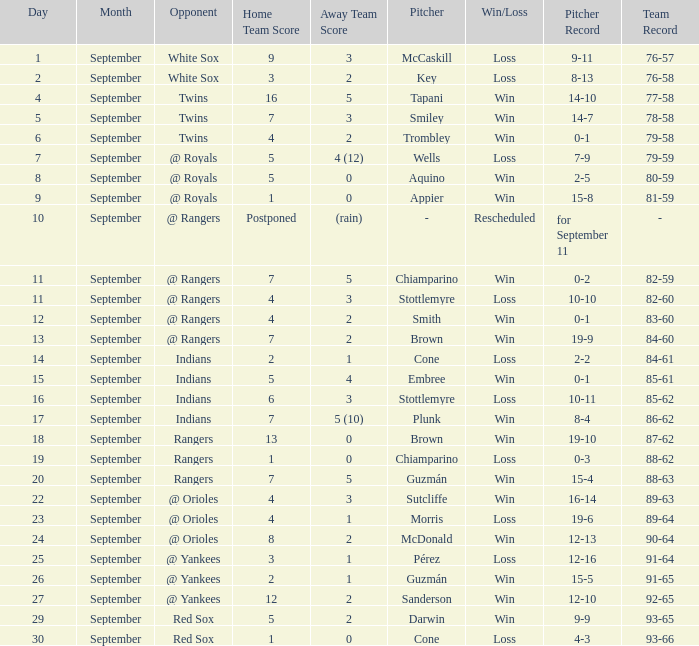Write the full table. {'header': ['Day', 'Month', 'Opponent', 'Home Team Score', 'Away Team Score', 'Pitcher', 'Win/Loss', 'Pitcher Record', 'Team Record'], 'rows': [['1', 'September', 'White Sox', '9', '3', 'McCaskill', 'Loss', '9-11', '76-57'], ['2', 'September', 'White Sox', '3', '2', 'Key', 'Loss', '8-13', '76-58'], ['4', 'September', 'Twins', '16', '5', 'Tapani', 'Win', '14-10', '77-58'], ['5', 'September', 'Twins', '7', '3', 'Smiley', 'Win', '14-7', '78-58'], ['6', 'September', 'Twins', '4', '2', 'Trombley', 'Win', '0-1', '79-58'], ['7', 'September', '@ Royals', '5', '4 (12)', 'Wells', 'Loss', '7-9', '79-59'], ['8', 'September', '@ Royals', '5', '0', 'Aquino', 'Win', '2-5', '80-59'], ['9', 'September', '@ Royals', '1', '0', 'Appier', 'Win', '15-8', '81-59'], ['10', 'September', '@ Rangers', 'Postponed', '(rain)', '-', 'Rescheduled', 'for September 11', '-'], ['11', 'September', '@ Rangers', '7', '5', 'Chiamparino', 'Win', '0-2', '82-59'], ['11', 'September', '@ Rangers', '4', '3', 'Stottlemyre', 'Loss', '10-10', '82-60'], ['12', 'September', '@ Rangers', '4', '2', 'Smith', 'Win', '0-1', '83-60'], ['13', 'September', '@ Rangers', '7', '2', 'Brown', 'Win', '19-9', '84-60'], ['14', 'September', 'Indians', '2', '1', 'Cone', 'Loss', '2-2', '84-61'], ['15', 'September', 'Indians', '5', '4', 'Embree', 'Win', '0-1', '85-61'], ['16', 'September', 'Indians', '6', '3', 'Stottlemyre', 'Loss', '10-11', '85-62'], ['17', 'September', 'Indians', '7', '5 (10)', 'Plunk', 'Win', '8-4', '86-62'], ['18', 'September', 'Rangers', '13', '0', 'Brown', 'Win', '19-10', '87-62'], ['19', 'September', 'Rangers', '1', '0', 'Chiamparino', 'Loss', '0-3', '88-62'], ['20', 'September', 'Rangers', '7', '5', 'Guzmán', 'Win', '15-4', '88-63'], ['22', 'September', '@ Orioles', '4', '3', 'Sutcliffe', 'Win', '16-14', '89-63'], ['23', 'September', '@ Orioles', '4', '1', 'Morris', 'Loss', '19-6', '89-64'], ['24', 'September', '@ Orioles', '8', '2', 'McDonald', 'Win', '12-13', '90-64'], ['25', 'September', '@ Yankees', '3', '1', 'Pérez', 'Loss', '12-16', '91-64'], ['26', 'September', '@ Yankees', '2', '1', 'Guzmán', 'Win', '15-5', '91-65'], ['27', 'September', '@ Yankees', '12', '2', 'Sanderson', 'Win', '12-10', '92-65'], ['29', 'September', 'Red Sox', '5', '2', 'Darwin', 'Win', '9-9', '93-65'], ['30', 'September', 'Red Sox', '1', '0', 'Cone', 'Loss', '4-3', '93-66']]} What's the loss for September 16? Stottlemyre (10-11). 